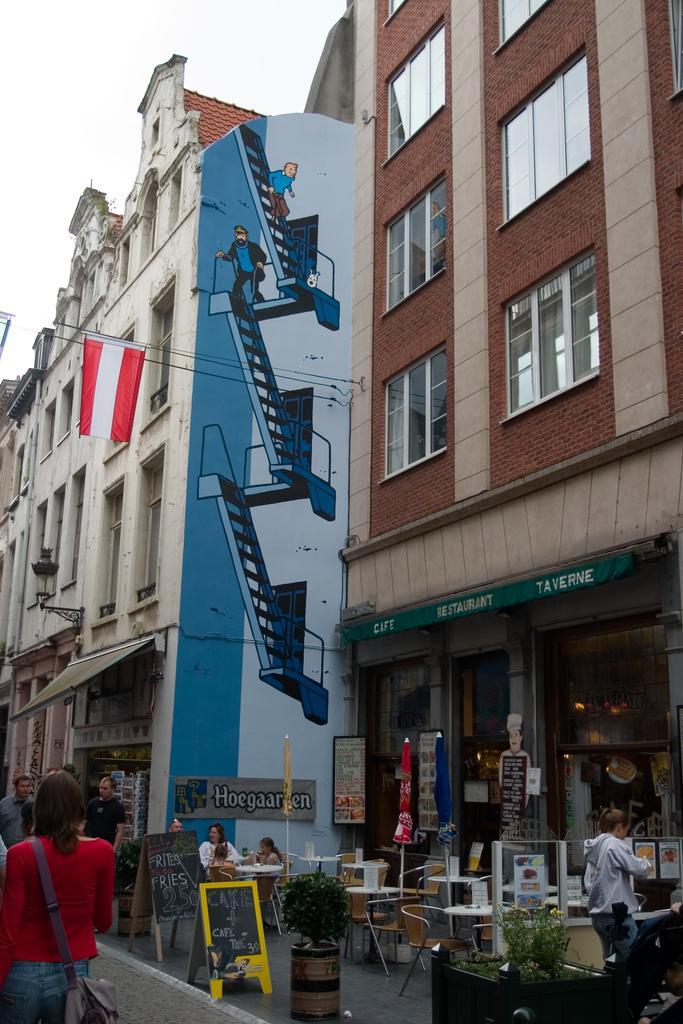Describe this image in one or two sentences. As we can see in the image there are buildings, banners, few people here and there, chairs, tables and plants. On building there is a drawing. On the top there is sky. 